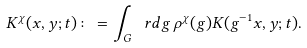<formula> <loc_0><loc_0><loc_500><loc_500>K ^ { \chi } ( x , y ; t ) \colon = \int _ { G } \ r d g \, \rho ^ { \chi } ( g ) K ( g ^ { - 1 } x , y ; t ) .</formula> 